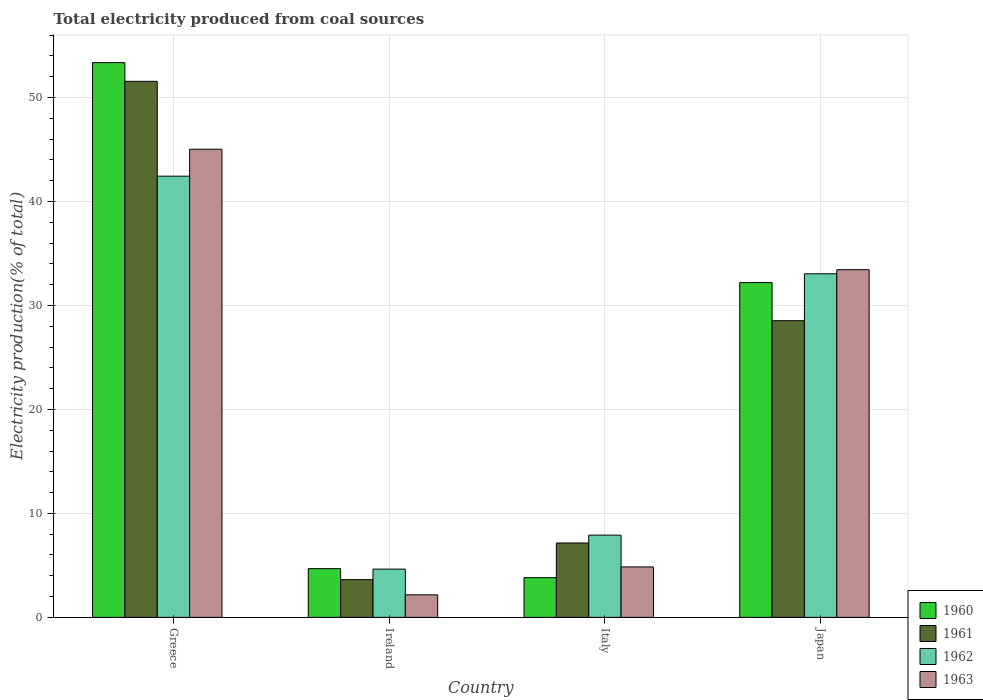How many different coloured bars are there?
Your answer should be very brief. 4. How many groups of bars are there?
Give a very brief answer. 4. Are the number of bars per tick equal to the number of legend labels?
Provide a short and direct response. Yes. Are the number of bars on each tick of the X-axis equal?
Offer a very short reply. Yes. How many bars are there on the 4th tick from the left?
Offer a very short reply. 4. How many bars are there on the 2nd tick from the right?
Your answer should be compact. 4. What is the label of the 4th group of bars from the left?
Your answer should be compact. Japan. What is the total electricity produced in 1963 in Greece?
Offer a very short reply. 45.03. Across all countries, what is the maximum total electricity produced in 1961?
Keep it short and to the point. 51.56. Across all countries, what is the minimum total electricity produced in 1961?
Ensure brevity in your answer.  3.63. In which country was the total electricity produced in 1962 minimum?
Provide a short and direct response. Ireland. What is the total total electricity produced in 1961 in the graph?
Your answer should be very brief. 90.88. What is the difference between the total electricity produced in 1963 in Ireland and that in Italy?
Provide a succinct answer. -2.69. What is the difference between the total electricity produced in 1960 in Greece and the total electricity produced in 1963 in Italy?
Your answer should be compact. 48.51. What is the average total electricity produced in 1962 per country?
Give a very brief answer. 22.01. What is the difference between the total electricity produced of/in 1960 and total electricity produced of/in 1962 in Ireland?
Give a very brief answer. 0.05. What is the ratio of the total electricity produced in 1962 in Ireland to that in Italy?
Provide a short and direct response. 0.59. Is the total electricity produced in 1963 in Ireland less than that in Italy?
Your response must be concise. Yes. What is the difference between the highest and the second highest total electricity produced in 1960?
Offer a terse response. 27.52. What is the difference between the highest and the lowest total electricity produced in 1961?
Your answer should be compact. 47.93. Is it the case that in every country, the sum of the total electricity produced in 1960 and total electricity produced in 1963 is greater than the sum of total electricity produced in 1961 and total electricity produced in 1962?
Offer a terse response. No. What does the 4th bar from the left in Italy represents?
Make the answer very short. 1963. Is it the case that in every country, the sum of the total electricity produced in 1960 and total electricity produced in 1962 is greater than the total electricity produced in 1961?
Offer a very short reply. Yes. How many countries are there in the graph?
Your response must be concise. 4. What is the difference between two consecutive major ticks on the Y-axis?
Your answer should be compact. 10. What is the title of the graph?
Give a very brief answer. Total electricity produced from coal sources. What is the label or title of the Y-axis?
Provide a short and direct response. Electricity production(% of total). What is the Electricity production(% of total) of 1960 in Greece?
Offer a terse response. 53.36. What is the Electricity production(% of total) in 1961 in Greece?
Offer a terse response. 51.56. What is the Electricity production(% of total) in 1962 in Greece?
Your answer should be compact. 42.44. What is the Electricity production(% of total) of 1963 in Greece?
Offer a terse response. 45.03. What is the Electricity production(% of total) in 1960 in Ireland?
Your response must be concise. 4.69. What is the Electricity production(% of total) in 1961 in Ireland?
Your answer should be very brief. 3.63. What is the Electricity production(% of total) in 1962 in Ireland?
Your answer should be very brief. 4.64. What is the Electricity production(% of total) of 1963 in Ireland?
Your answer should be compact. 2.16. What is the Electricity production(% of total) in 1960 in Italy?
Offer a terse response. 3.82. What is the Electricity production(% of total) in 1961 in Italy?
Your response must be concise. 7.15. What is the Electricity production(% of total) in 1962 in Italy?
Offer a very short reply. 7.91. What is the Electricity production(% of total) in 1963 in Italy?
Provide a succinct answer. 4.85. What is the Electricity production(% of total) in 1960 in Japan?
Provide a short and direct response. 32.21. What is the Electricity production(% of total) of 1961 in Japan?
Provide a succinct answer. 28.54. What is the Electricity production(% of total) in 1962 in Japan?
Offer a very short reply. 33.05. What is the Electricity production(% of total) in 1963 in Japan?
Give a very brief answer. 33.44. Across all countries, what is the maximum Electricity production(% of total) of 1960?
Provide a short and direct response. 53.36. Across all countries, what is the maximum Electricity production(% of total) of 1961?
Ensure brevity in your answer.  51.56. Across all countries, what is the maximum Electricity production(% of total) in 1962?
Give a very brief answer. 42.44. Across all countries, what is the maximum Electricity production(% of total) in 1963?
Your answer should be very brief. 45.03. Across all countries, what is the minimum Electricity production(% of total) of 1960?
Offer a very short reply. 3.82. Across all countries, what is the minimum Electricity production(% of total) of 1961?
Offer a terse response. 3.63. Across all countries, what is the minimum Electricity production(% of total) in 1962?
Your response must be concise. 4.64. Across all countries, what is the minimum Electricity production(% of total) of 1963?
Provide a short and direct response. 2.16. What is the total Electricity production(% of total) in 1960 in the graph?
Provide a succinct answer. 94.07. What is the total Electricity production(% of total) of 1961 in the graph?
Offer a very short reply. 90.88. What is the total Electricity production(% of total) in 1962 in the graph?
Offer a terse response. 88.04. What is the total Electricity production(% of total) of 1963 in the graph?
Offer a very short reply. 85.49. What is the difference between the Electricity production(% of total) of 1960 in Greece and that in Ireland?
Give a very brief answer. 48.68. What is the difference between the Electricity production(% of total) in 1961 in Greece and that in Ireland?
Your answer should be compact. 47.93. What is the difference between the Electricity production(% of total) in 1962 in Greece and that in Ireland?
Your answer should be very brief. 37.8. What is the difference between the Electricity production(% of total) in 1963 in Greece and that in Ireland?
Provide a succinct answer. 42.87. What is the difference between the Electricity production(% of total) of 1960 in Greece and that in Italy?
Provide a short and direct response. 49.54. What is the difference between the Electricity production(% of total) in 1961 in Greece and that in Italy?
Your answer should be very brief. 44.41. What is the difference between the Electricity production(% of total) in 1962 in Greece and that in Italy?
Your answer should be very brief. 34.53. What is the difference between the Electricity production(% of total) in 1963 in Greece and that in Italy?
Make the answer very short. 40.18. What is the difference between the Electricity production(% of total) of 1960 in Greece and that in Japan?
Give a very brief answer. 21.15. What is the difference between the Electricity production(% of total) of 1961 in Greece and that in Japan?
Provide a succinct answer. 23.02. What is the difference between the Electricity production(% of total) in 1962 in Greece and that in Japan?
Offer a terse response. 9.39. What is the difference between the Electricity production(% of total) of 1963 in Greece and that in Japan?
Keep it short and to the point. 11.59. What is the difference between the Electricity production(% of total) of 1960 in Ireland and that in Italy?
Offer a terse response. 0.87. What is the difference between the Electricity production(% of total) in 1961 in Ireland and that in Italy?
Offer a terse response. -3.53. What is the difference between the Electricity production(% of total) of 1962 in Ireland and that in Italy?
Your answer should be compact. -3.27. What is the difference between the Electricity production(% of total) of 1963 in Ireland and that in Italy?
Your answer should be compact. -2.69. What is the difference between the Electricity production(% of total) of 1960 in Ireland and that in Japan?
Make the answer very short. -27.52. What is the difference between the Electricity production(% of total) of 1961 in Ireland and that in Japan?
Your answer should be very brief. -24.91. What is the difference between the Electricity production(% of total) in 1962 in Ireland and that in Japan?
Give a very brief answer. -28.41. What is the difference between the Electricity production(% of total) in 1963 in Ireland and that in Japan?
Ensure brevity in your answer.  -31.28. What is the difference between the Electricity production(% of total) of 1960 in Italy and that in Japan?
Your response must be concise. -28.39. What is the difference between the Electricity production(% of total) in 1961 in Italy and that in Japan?
Offer a very short reply. -21.38. What is the difference between the Electricity production(% of total) of 1962 in Italy and that in Japan?
Provide a short and direct response. -25.14. What is the difference between the Electricity production(% of total) in 1963 in Italy and that in Japan?
Offer a very short reply. -28.59. What is the difference between the Electricity production(% of total) in 1960 in Greece and the Electricity production(% of total) in 1961 in Ireland?
Give a very brief answer. 49.73. What is the difference between the Electricity production(% of total) of 1960 in Greece and the Electricity production(% of total) of 1962 in Ireland?
Your answer should be compact. 48.72. What is the difference between the Electricity production(% of total) in 1960 in Greece and the Electricity production(% of total) in 1963 in Ireland?
Keep it short and to the point. 51.2. What is the difference between the Electricity production(% of total) in 1961 in Greece and the Electricity production(% of total) in 1962 in Ireland?
Provide a short and direct response. 46.92. What is the difference between the Electricity production(% of total) of 1961 in Greece and the Electricity production(% of total) of 1963 in Ireland?
Provide a succinct answer. 49.4. What is the difference between the Electricity production(% of total) in 1962 in Greece and the Electricity production(% of total) in 1963 in Ireland?
Offer a terse response. 40.27. What is the difference between the Electricity production(% of total) of 1960 in Greece and the Electricity production(% of total) of 1961 in Italy?
Provide a short and direct response. 46.21. What is the difference between the Electricity production(% of total) of 1960 in Greece and the Electricity production(% of total) of 1962 in Italy?
Your answer should be very brief. 45.45. What is the difference between the Electricity production(% of total) of 1960 in Greece and the Electricity production(% of total) of 1963 in Italy?
Provide a short and direct response. 48.51. What is the difference between the Electricity production(% of total) of 1961 in Greece and the Electricity production(% of total) of 1962 in Italy?
Make the answer very short. 43.65. What is the difference between the Electricity production(% of total) in 1961 in Greece and the Electricity production(% of total) in 1963 in Italy?
Your answer should be very brief. 46.71. What is the difference between the Electricity production(% of total) of 1962 in Greece and the Electricity production(% of total) of 1963 in Italy?
Give a very brief answer. 37.59. What is the difference between the Electricity production(% of total) in 1960 in Greece and the Electricity production(% of total) in 1961 in Japan?
Your response must be concise. 24.82. What is the difference between the Electricity production(% of total) of 1960 in Greece and the Electricity production(% of total) of 1962 in Japan?
Offer a very short reply. 20.31. What is the difference between the Electricity production(% of total) in 1960 in Greece and the Electricity production(% of total) in 1963 in Japan?
Offer a very short reply. 19.92. What is the difference between the Electricity production(% of total) in 1961 in Greece and the Electricity production(% of total) in 1962 in Japan?
Provide a succinct answer. 18.51. What is the difference between the Electricity production(% of total) of 1961 in Greece and the Electricity production(% of total) of 1963 in Japan?
Offer a very short reply. 18.12. What is the difference between the Electricity production(% of total) of 1962 in Greece and the Electricity production(% of total) of 1963 in Japan?
Offer a terse response. 9. What is the difference between the Electricity production(% of total) in 1960 in Ireland and the Electricity production(% of total) in 1961 in Italy?
Your response must be concise. -2.47. What is the difference between the Electricity production(% of total) in 1960 in Ireland and the Electricity production(% of total) in 1962 in Italy?
Make the answer very short. -3.22. What is the difference between the Electricity production(% of total) of 1960 in Ireland and the Electricity production(% of total) of 1963 in Italy?
Ensure brevity in your answer.  -0.17. What is the difference between the Electricity production(% of total) of 1961 in Ireland and the Electricity production(% of total) of 1962 in Italy?
Your response must be concise. -4.28. What is the difference between the Electricity production(% of total) in 1961 in Ireland and the Electricity production(% of total) in 1963 in Italy?
Your response must be concise. -1.22. What is the difference between the Electricity production(% of total) in 1962 in Ireland and the Electricity production(% of total) in 1963 in Italy?
Offer a terse response. -0.21. What is the difference between the Electricity production(% of total) in 1960 in Ireland and the Electricity production(% of total) in 1961 in Japan?
Offer a very short reply. -23.85. What is the difference between the Electricity production(% of total) in 1960 in Ireland and the Electricity production(% of total) in 1962 in Japan?
Offer a very short reply. -28.36. What is the difference between the Electricity production(% of total) in 1960 in Ireland and the Electricity production(% of total) in 1963 in Japan?
Give a very brief answer. -28.76. What is the difference between the Electricity production(% of total) in 1961 in Ireland and the Electricity production(% of total) in 1962 in Japan?
Your answer should be very brief. -29.42. What is the difference between the Electricity production(% of total) in 1961 in Ireland and the Electricity production(% of total) in 1963 in Japan?
Your response must be concise. -29.82. What is the difference between the Electricity production(% of total) in 1962 in Ireland and the Electricity production(% of total) in 1963 in Japan?
Keep it short and to the point. -28.8. What is the difference between the Electricity production(% of total) of 1960 in Italy and the Electricity production(% of total) of 1961 in Japan?
Offer a terse response. -24.72. What is the difference between the Electricity production(% of total) of 1960 in Italy and the Electricity production(% of total) of 1962 in Japan?
Offer a very short reply. -29.23. What is the difference between the Electricity production(% of total) of 1960 in Italy and the Electricity production(% of total) of 1963 in Japan?
Ensure brevity in your answer.  -29.63. What is the difference between the Electricity production(% of total) in 1961 in Italy and the Electricity production(% of total) in 1962 in Japan?
Provide a short and direct response. -25.89. What is the difference between the Electricity production(% of total) of 1961 in Italy and the Electricity production(% of total) of 1963 in Japan?
Provide a short and direct response. -26.29. What is the difference between the Electricity production(% of total) in 1962 in Italy and the Electricity production(% of total) in 1963 in Japan?
Offer a terse response. -25.53. What is the average Electricity production(% of total) in 1960 per country?
Keep it short and to the point. 23.52. What is the average Electricity production(% of total) in 1961 per country?
Your response must be concise. 22.72. What is the average Electricity production(% of total) in 1962 per country?
Offer a very short reply. 22.01. What is the average Electricity production(% of total) of 1963 per country?
Ensure brevity in your answer.  21.37. What is the difference between the Electricity production(% of total) in 1960 and Electricity production(% of total) in 1961 in Greece?
Give a very brief answer. 1.8. What is the difference between the Electricity production(% of total) of 1960 and Electricity production(% of total) of 1962 in Greece?
Ensure brevity in your answer.  10.92. What is the difference between the Electricity production(% of total) in 1960 and Electricity production(% of total) in 1963 in Greece?
Ensure brevity in your answer.  8.33. What is the difference between the Electricity production(% of total) of 1961 and Electricity production(% of total) of 1962 in Greece?
Provide a succinct answer. 9.12. What is the difference between the Electricity production(% of total) of 1961 and Electricity production(% of total) of 1963 in Greece?
Provide a short and direct response. 6.53. What is the difference between the Electricity production(% of total) in 1962 and Electricity production(% of total) in 1963 in Greece?
Your answer should be very brief. -2.59. What is the difference between the Electricity production(% of total) in 1960 and Electricity production(% of total) in 1961 in Ireland?
Your answer should be very brief. 1.06. What is the difference between the Electricity production(% of total) in 1960 and Electricity production(% of total) in 1962 in Ireland?
Provide a succinct answer. 0.05. What is the difference between the Electricity production(% of total) of 1960 and Electricity production(% of total) of 1963 in Ireland?
Provide a short and direct response. 2.52. What is the difference between the Electricity production(% of total) in 1961 and Electricity production(% of total) in 1962 in Ireland?
Make the answer very short. -1.01. What is the difference between the Electricity production(% of total) in 1961 and Electricity production(% of total) in 1963 in Ireland?
Make the answer very short. 1.46. What is the difference between the Electricity production(% of total) in 1962 and Electricity production(% of total) in 1963 in Ireland?
Your answer should be compact. 2.48. What is the difference between the Electricity production(% of total) of 1960 and Electricity production(% of total) of 1961 in Italy?
Give a very brief answer. -3.34. What is the difference between the Electricity production(% of total) of 1960 and Electricity production(% of total) of 1962 in Italy?
Keep it short and to the point. -4.09. What is the difference between the Electricity production(% of total) of 1960 and Electricity production(% of total) of 1963 in Italy?
Keep it short and to the point. -1.03. What is the difference between the Electricity production(% of total) in 1961 and Electricity production(% of total) in 1962 in Italy?
Give a very brief answer. -0.75. What is the difference between the Electricity production(% of total) in 1961 and Electricity production(% of total) in 1963 in Italy?
Provide a short and direct response. 2.3. What is the difference between the Electricity production(% of total) of 1962 and Electricity production(% of total) of 1963 in Italy?
Offer a very short reply. 3.06. What is the difference between the Electricity production(% of total) of 1960 and Electricity production(% of total) of 1961 in Japan?
Make the answer very short. 3.67. What is the difference between the Electricity production(% of total) of 1960 and Electricity production(% of total) of 1962 in Japan?
Your answer should be compact. -0.84. What is the difference between the Electricity production(% of total) in 1960 and Electricity production(% of total) in 1963 in Japan?
Make the answer very short. -1.24. What is the difference between the Electricity production(% of total) of 1961 and Electricity production(% of total) of 1962 in Japan?
Provide a succinct answer. -4.51. What is the difference between the Electricity production(% of total) in 1961 and Electricity production(% of total) in 1963 in Japan?
Your answer should be very brief. -4.9. What is the difference between the Electricity production(% of total) of 1962 and Electricity production(% of total) of 1963 in Japan?
Provide a short and direct response. -0.4. What is the ratio of the Electricity production(% of total) of 1960 in Greece to that in Ireland?
Offer a terse response. 11.39. What is the ratio of the Electricity production(% of total) in 1961 in Greece to that in Ireland?
Give a very brief answer. 14.21. What is the ratio of the Electricity production(% of total) in 1962 in Greece to that in Ireland?
Ensure brevity in your answer.  9.14. What is the ratio of the Electricity production(% of total) in 1963 in Greece to that in Ireland?
Keep it short and to the point. 20.8. What is the ratio of the Electricity production(% of total) in 1960 in Greece to that in Italy?
Offer a very short reply. 13.97. What is the ratio of the Electricity production(% of total) in 1961 in Greece to that in Italy?
Give a very brief answer. 7.21. What is the ratio of the Electricity production(% of total) in 1962 in Greece to that in Italy?
Give a very brief answer. 5.37. What is the ratio of the Electricity production(% of total) in 1963 in Greece to that in Italy?
Your answer should be very brief. 9.28. What is the ratio of the Electricity production(% of total) in 1960 in Greece to that in Japan?
Provide a succinct answer. 1.66. What is the ratio of the Electricity production(% of total) in 1961 in Greece to that in Japan?
Your response must be concise. 1.81. What is the ratio of the Electricity production(% of total) in 1962 in Greece to that in Japan?
Provide a short and direct response. 1.28. What is the ratio of the Electricity production(% of total) in 1963 in Greece to that in Japan?
Provide a succinct answer. 1.35. What is the ratio of the Electricity production(% of total) in 1960 in Ireland to that in Italy?
Offer a very short reply. 1.23. What is the ratio of the Electricity production(% of total) in 1961 in Ireland to that in Italy?
Your response must be concise. 0.51. What is the ratio of the Electricity production(% of total) of 1962 in Ireland to that in Italy?
Offer a terse response. 0.59. What is the ratio of the Electricity production(% of total) in 1963 in Ireland to that in Italy?
Keep it short and to the point. 0.45. What is the ratio of the Electricity production(% of total) in 1960 in Ireland to that in Japan?
Ensure brevity in your answer.  0.15. What is the ratio of the Electricity production(% of total) in 1961 in Ireland to that in Japan?
Your answer should be compact. 0.13. What is the ratio of the Electricity production(% of total) of 1962 in Ireland to that in Japan?
Your answer should be very brief. 0.14. What is the ratio of the Electricity production(% of total) of 1963 in Ireland to that in Japan?
Ensure brevity in your answer.  0.06. What is the ratio of the Electricity production(% of total) in 1960 in Italy to that in Japan?
Keep it short and to the point. 0.12. What is the ratio of the Electricity production(% of total) of 1961 in Italy to that in Japan?
Keep it short and to the point. 0.25. What is the ratio of the Electricity production(% of total) in 1962 in Italy to that in Japan?
Your answer should be very brief. 0.24. What is the ratio of the Electricity production(% of total) of 1963 in Italy to that in Japan?
Your answer should be very brief. 0.15. What is the difference between the highest and the second highest Electricity production(% of total) of 1960?
Offer a terse response. 21.15. What is the difference between the highest and the second highest Electricity production(% of total) in 1961?
Give a very brief answer. 23.02. What is the difference between the highest and the second highest Electricity production(% of total) in 1962?
Provide a short and direct response. 9.39. What is the difference between the highest and the second highest Electricity production(% of total) of 1963?
Offer a terse response. 11.59. What is the difference between the highest and the lowest Electricity production(% of total) in 1960?
Your answer should be very brief. 49.54. What is the difference between the highest and the lowest Electricity production(% of total) in 1961?
Give a very brief answer. 47.93. What is the difference between the highest and the lowest Electricity production(% of total) in 1962?
Offer a very short reply. 37.8. What is the difference between the highest and the lowest Electricity production(% of total) of 1963?
Keep it short and to the point. 42.87. 